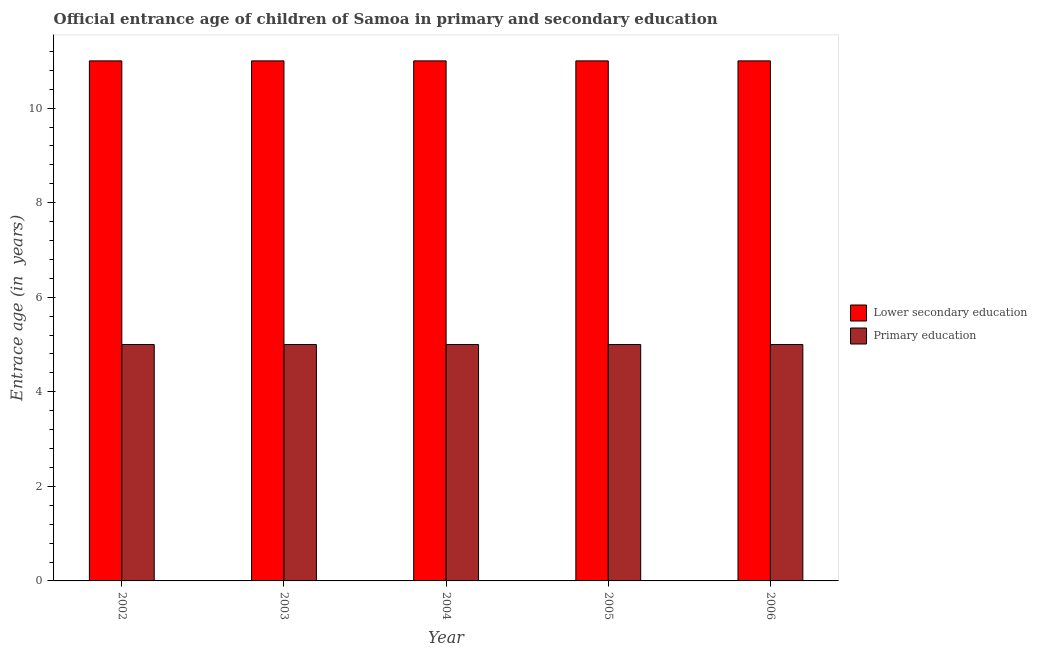How many different coloured bars are there?
Make the answer very short. 2. How many groups of bars are there?
Your answer should be compact. 5. Are the number of bars per tick equal to the number of legend labels?
Your response must be concise. Yes. Are the number of bars on each tick of the X-axis equal?
Your answer should be compact. Yes. How many bars are there on the 5th tick from the left?
Keep it short and to the point. 2. What is the label of the 4th group of bars from the left?
Provide a short and direct response. 2005. What is the entrance age of chiildren in primary education in 2006?
Your answer should be compact. 5. Across all years, what is the maximum entrance age of children in lower secondary education?
Provide a short and direct response. 11. Across all years, what is the minimum entrance age of chiildren in primary education?
Your answer should be very brief. 5. In which year was the entrance age of chiildren in primary education maximum?
Ensure brevity in your answer.  2002. What is the total entrance age of children in lower secondary education in the graph?
Your response must be concise. 55. What is the difference between the entrance age of children in lower secondary education in 2005 and the entrance age of chiildren in primary education in 2004?
Provide a short and direct response. 0. What is the average entrance age of children in lower secondary education per year?
Make the answer very short. 11. In the year 2005, what is the difference between the entrance age of chiildren in primary education and entrance age of children in lower secondary education?
Your response must be concise. 0. In how many years, is the entrance age of children in lower secondary education greater than 3.6 years?
Provide a succinct answer. 5. What is the difference between the highest and the second highest entrance age of chiildren in primary education?
Keep it short and to the point. 0. What does the 1st bar from the left in 2005 represents?
Your answer should be compact. Lower secondary education. How many bars are there?
Ensure brevity in your answer.  10. Are all the bars in the graph horizontal?
Keep it short and to the point. No. What is the difference between two consecutive major ticks on the Y-axis?
Provide a short and direct response. 2. How many legend labels are there?
Your response must be concise. 2. What is the title of the graph?
Make the answer very short. Official entrance age of children of Samoa in primary and secondary education. Does "Investments" appear as one of the legend labels in the graph?
Keep it short and to the point. No. What is the label or title of the Y-axis?
Offer a terse response. Entrace age (in  years). What is the Entrace age (in  years) of Lower secondary education in 2004?
Provide a short and direct response. 11. What is the Entrace age (in  years) in Primary education in 2004?
Ensure brevity in your answer.  5. What is the Entrace age (in  years) in Lower secondary education in 2006?
Your answer should be compact. 11. Across all years, what is the maximum Entrace age (in  years) of Primary education?
Give a very brief answer. 5. Across all years, what is the minimum Entrace age (in  years) in Lower secondary education?
Provide a short and direct response. 11. What is the total Entrace age (in  years) of Lower secondary education in the graph?
Provide a succinct answer. 55. What is the difference between the Entrace age (in  years) in Primary education in 2002 and that in 2003?
Make the answer very short. 0. What is the difference between the Entrace age (in  years) of Lower secondary education in 2002 and that in 2005?
Your answer should be compact. 0. What is the difference between the Entrace age (in  years) in Lower secondary education in 2002 and that in 2006?
Provide a short and direct response. 0. What is the difference between the Entrace age (in  years) in Lower secondary education in 2003 and that in 2004?
Ensure brevity in your answer.  0. What is the difference between the Entrace age (in  years) in Lower secondary education in 2003 and that in 2005?
Your answer should be compact. 0. What is the difference between the Entrace age (in  years) of Primary education in 2003 and that in 2005?
Your answer should be very brief. 0. What is the difference between the Entrace age (in  years) of Lower secondary education in 2003 and that in 2006?
Provide a short and direct response. 0. What is the difference between the Entrace age (in  years) of Primary education in 2003 and that in 2006?
Make the answer very short. 0. What is the difference between the Entrace age (in  years) of Lower secondary education in 2004 and that in 2005?
Provide a short and direct response. 0. What is the difference between the Entrace age (in  years) of Primary education in 2004 and that in 2005?
Your response must be concise. 0. What is the difference between the Entrace age (in  years) in Lower secondary education in 2005 and that in 2006?
Offer a very short reply. 0. What is the difference between the Entrace age (in  years) of Lower secondary education in 2002 and the Entrace age (in  years) of Primary education in 2005?
Offer a terse response. 6. What is the difference between the Entrace age (in  years) of Lower secondary education in 2003 and the Entrace age (in  years) of Primary education in 2005?
Provide a succinct answer. 6. What is the difference between the Entrace age (in  years) in Lower secondary education in 2004 and the Entrace age (in  years) in Primary education in 2005?
Provide a succinct answer. 6. What is the difference between the Entrace age (in  years) of Lower secondary education in 2004 and the Entrace age (in  years) of Primary education in 2006?
Give a very brief answer. 6. What is the average Entrace age (in  years) of Lower secondary education per year?
Keep it short and to the point. 11. What is the average Entrace age (in  years) in Primary education per year?
Offer a very short reply. 5. In the year 2002, what is the difference between the Entrace age (in  years) of Lower secondary education and Entrace age (in  years) of Primary education?
Your answer should be very brief. 6. In the year 2003, what is the difference between the Entrace age (in  years) of Lower secondary education and Entrace age (in  years) of Primary education?
Your answer should be compact. 6. In the year 2006, what is the difference between the Entrace age (in  years) in Lower secondary education and Entrace age (in  years) in Primary education?
Make the answer very short. 6. What is the ratio of the Entrace age (in  years) of Lower secondary education in 2002 to that in 2003?
Your response must be concise. 1. What is the ratio of the Entrace age (in  years) in Lower secondary education in 2002 to that in 2004?
Keep it short and to the point. 1. What is the ratio of the Entrace age (in  years) in Primary education in 2002 to that in 2004?
Provide a short and direct response. 1. What is the ratio of the Entrace age (in  years) of Lower secondary education in 2002 to that in 2005?
Make the answer very short. 1. What is the ratio of the Entrace age (in  years) of Lower secondary education in 2002 to that in 2006?
Your response must be concise. 1. What is the ratio of the Entrace age (in  years) in Primary education in 2002 to that in 2006?
Ensure brevity in your answer.  1. What is the ratio of the Entrace age (in  years) in Primary education in 2003 to that in 2004?
Give a very brief answer. 1. What is the ratio of the Entrace age (in  years) of Lower secondary education in 2003 to that in 2005?
Give a very brief answer. 1. What is the ratio of the Entrace age (in  years) of Primary education in 2003 to that in 2005?
Your answer should be very brief. 1. What is the ratio of the Entrace age (in  years) of Lower secondary education in 2004 to that in 2006?
Offer a very short reply. 1. What is the ratio of the Entrace age (in  years) of Primary education in 2004 to that in 2006?
Give a very brief answer. 1. What is the ratio of the Entrace age (in  years) of Lower secondary education in 2005 to that in 2006?
Ensure brevity in your answer.  1. What is the ratio of the Entrace age (in  years) in Primary education in 2005 to that in 2006?
Make the answer very short. 1. What is the difference between the highest and the second highest Entrace age (in  years) of Primary education?
Offer a terse response. 0. What is the difference between the highest and the lowest Entrace age (in  years) in Lower secondary education?
Make the answer very short. 0. 